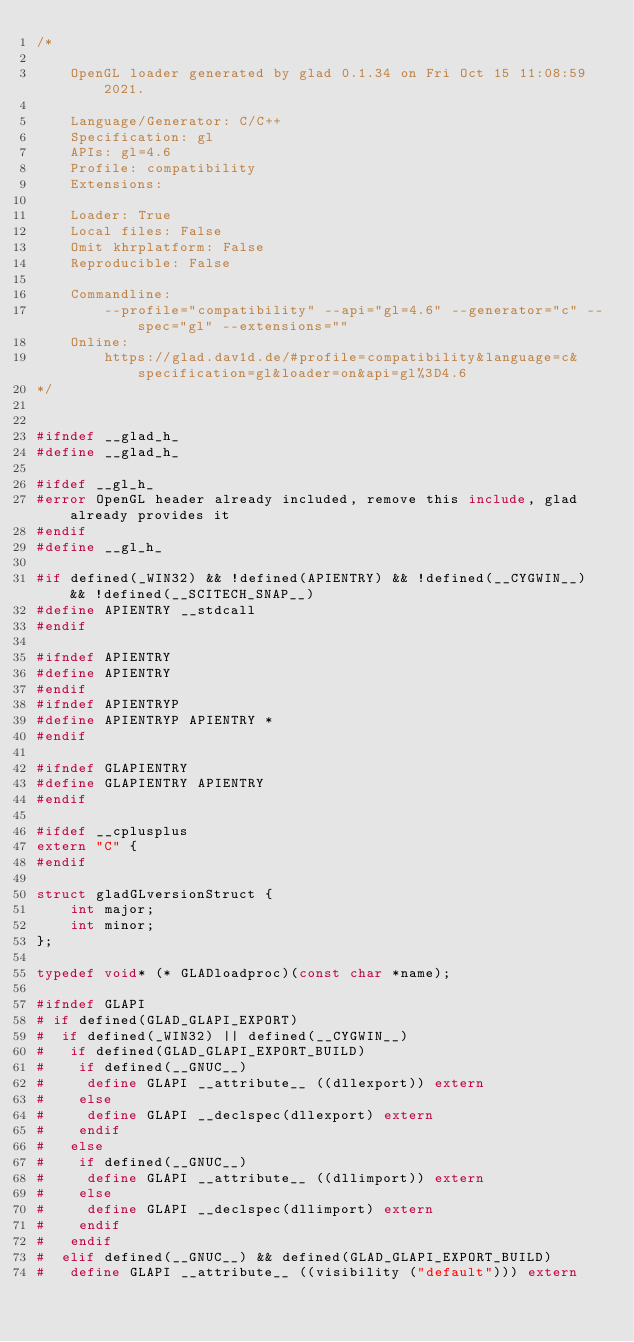<code> <loc_0><loc_0><loc_500><loc_500><_C_>/*

    OpenGL loader generated by glad 0.1.34 on Fri Oct 15 11:08:59 2021.

    Language/Generator: C/C++
    Specification: gl
    APIs: gl=4.6
    Profile: compatibility
    Extensions:
        
    Loader: True
    Local files: False
    Omit khrplatform: False
    Reproducible: False

    Commandline:
        --profile="compatibility" --api="gl=4.6" --generator="c" --spec="gl" --extensions=""
    Online:
        https://glad.dav1d.de/#profile=compatibility&language=c&specification=gl&loader=on&api=gl%3D4.6
*/


#ifndef __glad_h_
#define __glad_h_

#ifdef __gl_h_
#error OpenGL header already included, remove this include, glad already provides it
#endif
#define __gl_h_

#if defined(_WIN32) && !defined(APIENTRY) && !defined(__CYGWIN__) && !defined(__SCITECH_SNAP__)
#define APIENTRY __stdcall
#endif

#ifndef APIENTRY
#define APIENTRY
#endif
#ifndef APIENTRYP
#define APIENTRYP APIENTRY *
#endif

#ifndef GLAPIENTRY
#define GLAPIENTRY APIENTRY
#endif

#ifdef __cplusplus
extern "C" {
#endif

struct gladGLversionStruct {
    int major;
    int minor;
};

typedef void* (* GLADloadproc)(const char *name);

#ifndef GLAPI
# if defined(GLAD_GLAPI_EXPORT)
#  if defined(_WIN32) || defined(__CYGWIN__)
#   if defined(GLAD_GLAPI_EXPORT_BUILD)
#    if defined(__GNUC__)
#     define GLAPI __attribute__ ((dllexport)) extern
#    else
#     define GLAPI __declspec(dllexport) extern
#    endif
#   else
#    if defined(__GNUC__)
#     define GLAPI __attribute__ ((dllimport)) extern
#    else
#     define GLAPI __declspec(dllimport) extern
#    endif
#   endif
#  elif defined(__GNUC__) && defined(GLAD_GLAPI_EXPORT_BUILD)
#   define GLAPI __attribute__ ((visibility ("default"))) extern</code> 